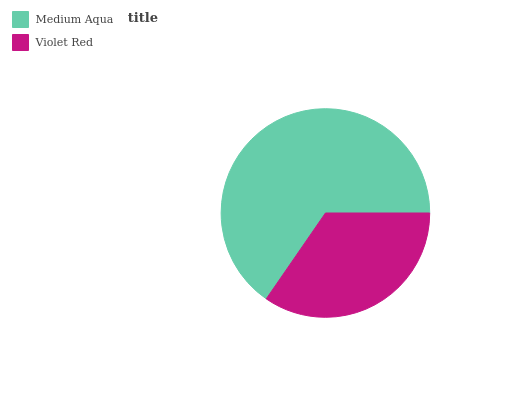Is Violet Red the minimum?
Answer yes or no. Yes. Is Medium Aqua the maximum?
Answer yes or no. Yes. Is Violet Red the maximum?
Answer yes or no. No. Is Medium Aqua greater than Violet Red?
Answer yes or no. Yes. Is Violet Red less than Medium Aqua?
Answer yes or no. Yes. Is Violet Red greater than Medium Aqua?
Answer yes or no. No. Is Medium Aqua less than Violet Red?
Answer yes or no. No. Is Medium Aqua the high median?
Answer yes or no. Yes. Is Violet Red the low median?
Answer yes or no. Yes. Is Violet Red the high median?
Answer yes or no. No. Is Medium Aqua the low median?
Answer yes or no. No. 